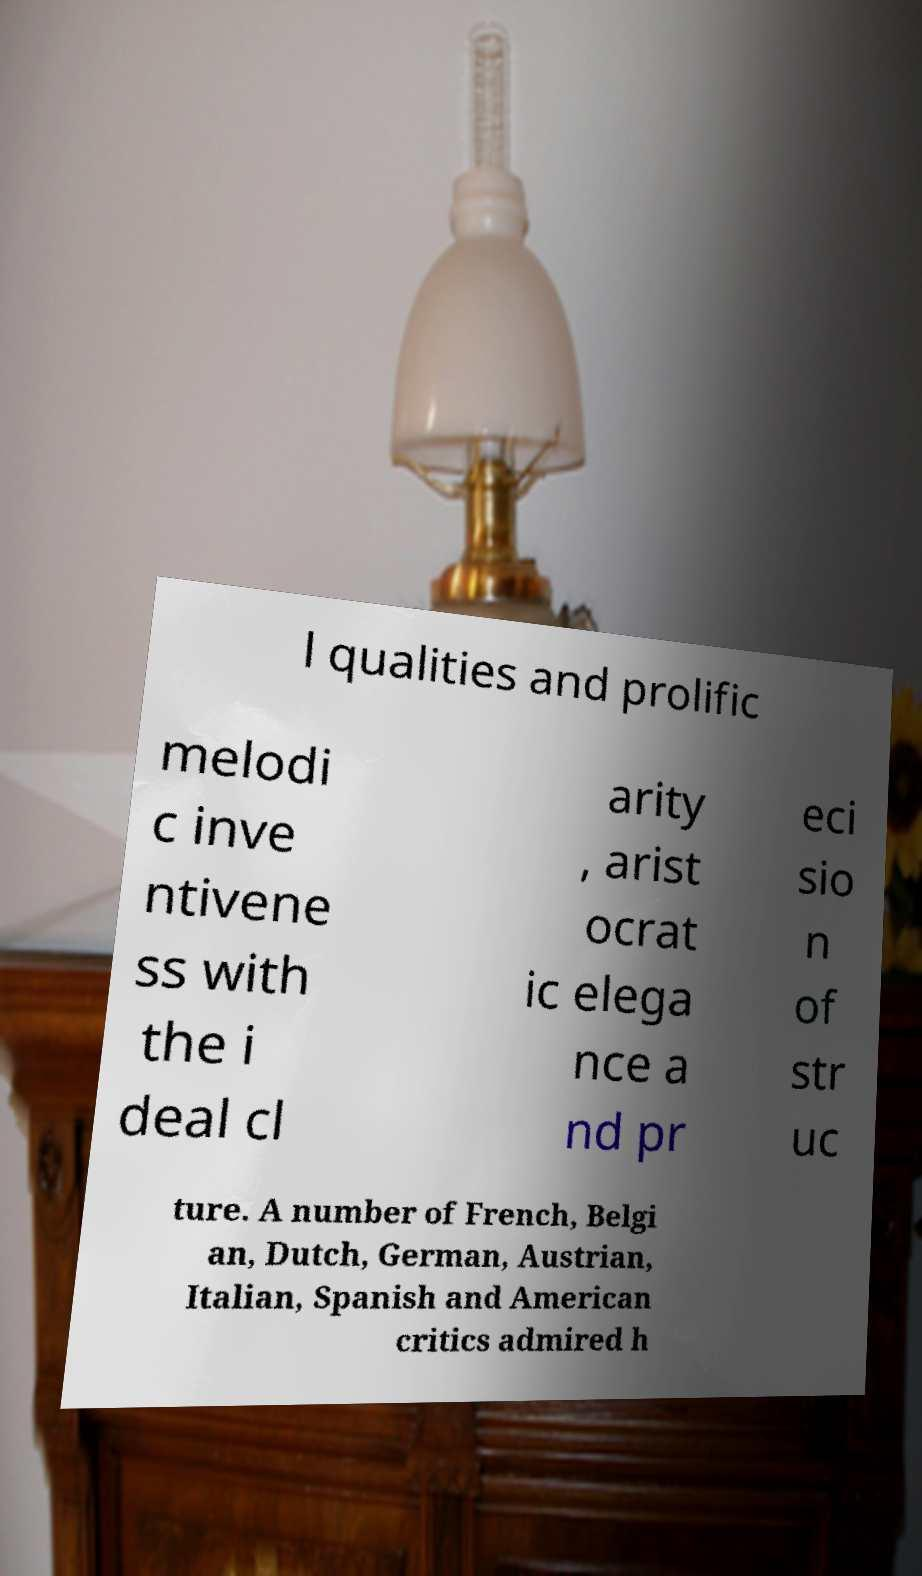For documentation purposes, I need the text within this image transcribed. Could you provide that? l qualities and prolific melodi c inve ntivene ss with the i deal cl arity , arist ocrat ic elega nce a nd pr eci sio n of str uc ture. A number of French, Belgi an, Dutch, German, Austrian, Italian, Spanish and American critics admired h 